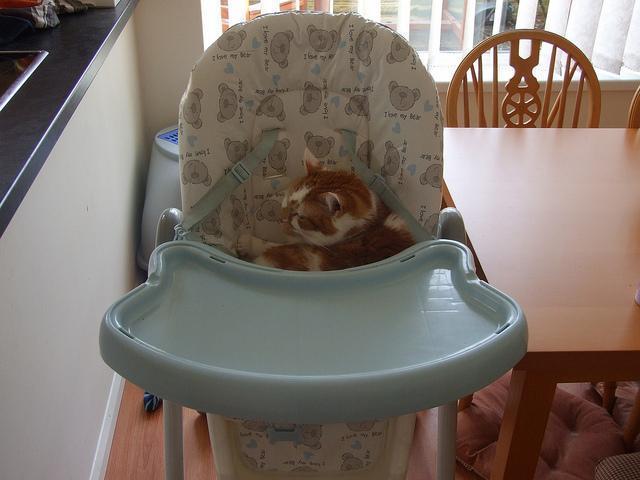How many chairs are visible?
Give a very brief answer. 2. How many men are wearing green underwear?
Give a very brief answer. 0. 